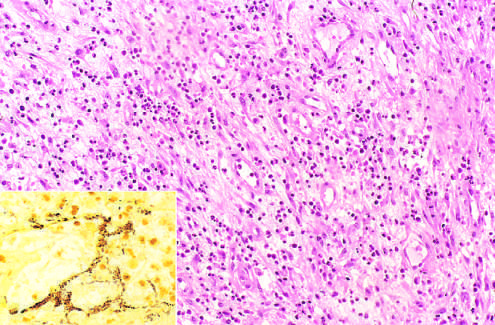what does modified silver stain demonstrate?
Answer the question using a single word or phrase. Clusters of tangled bacilli 